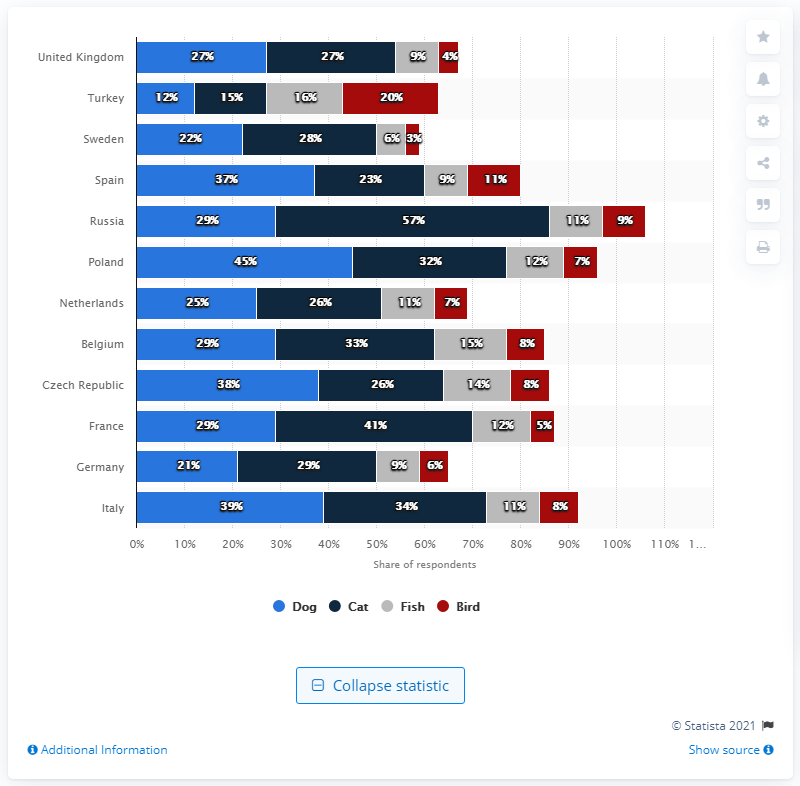Give some essential details in this illustration. Russia has the greatest pet ownership among all countries. Poland is known for having the second largest pet ownership in the world. 